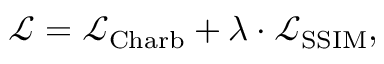<formula> <loc_0><loc_0><loc_500><loc_500>\begin{array} { r } { \mathcal { L } = \mathcal { L } _ { C h a r b } + \lambda \cdot \mathcal { L } _ { S S I M } , } \end{array}</formula> 